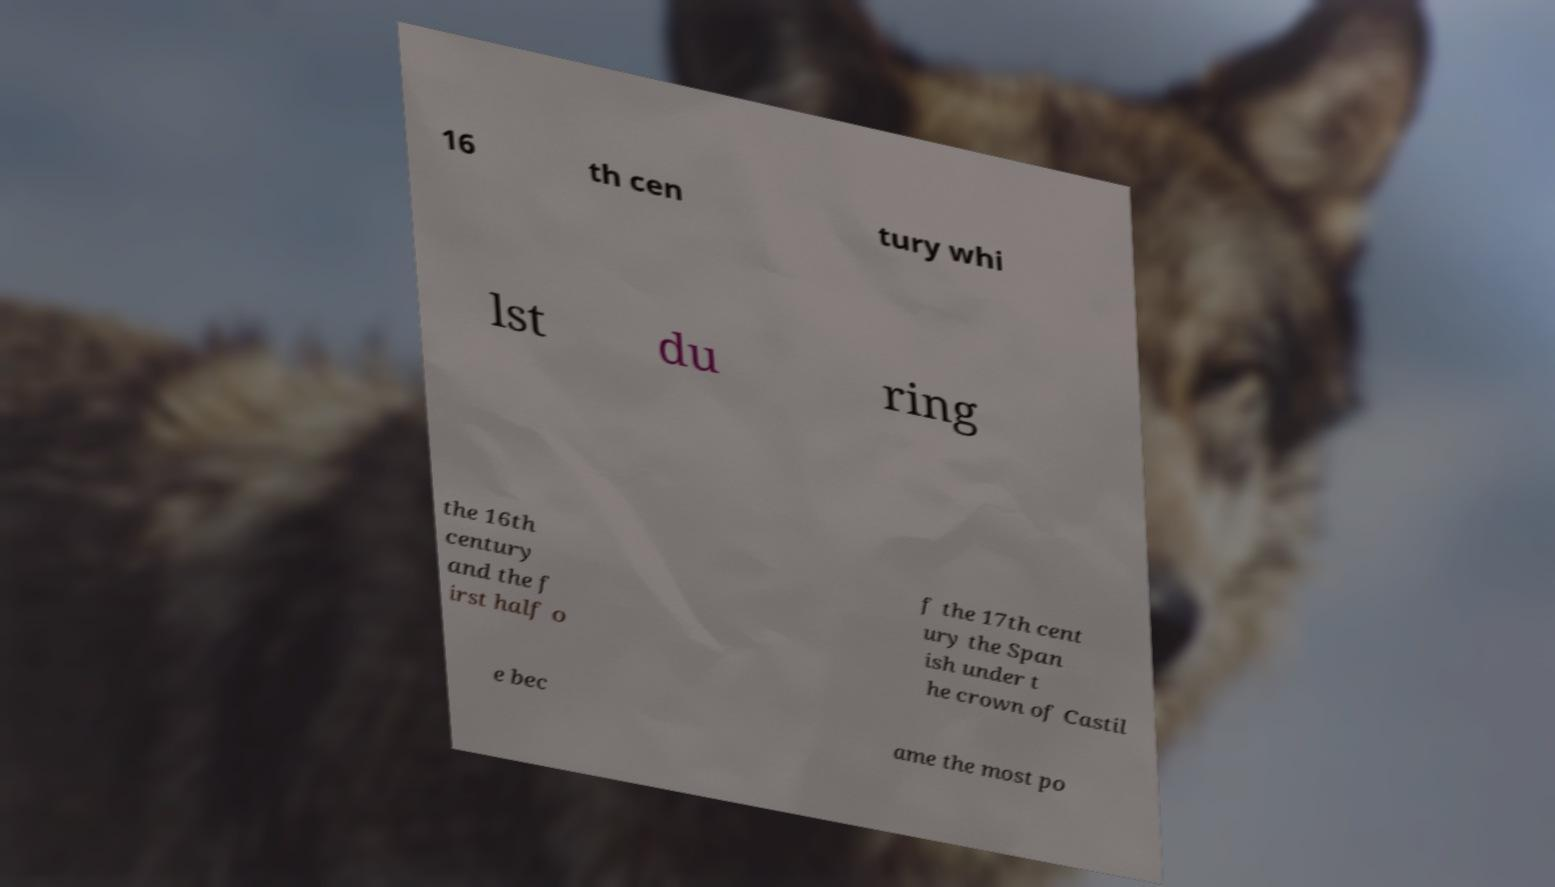There's text embedded in this image that I need extracted. Can you transcribe it verbatim? 16 th cen tury whi lst du ring the 16th century and the f irst half o f the 17th cent ury the Span ish under t he crown of Castil e bec ame the most po 